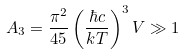<formula> <loc_0><loc_0><loc_500><loc_500>A _ { 3 } = \frac { \pi ^ { 2 } } { 4 5 } \left ( \frac { \hbar { c } } { k T } \right ) ^ { 3 } V \gg 1</formula> 